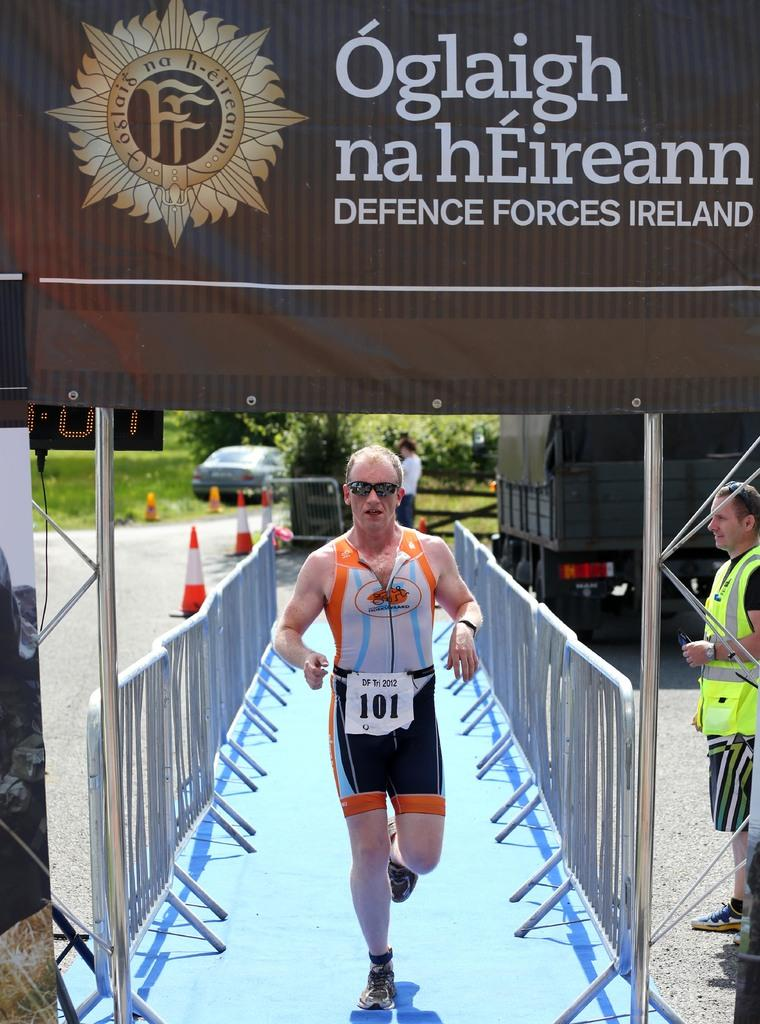<image>
Share a concise interpretation of the image provided. Runner number 101 reaching the finish line under a Defence Forces Ireland banner. 